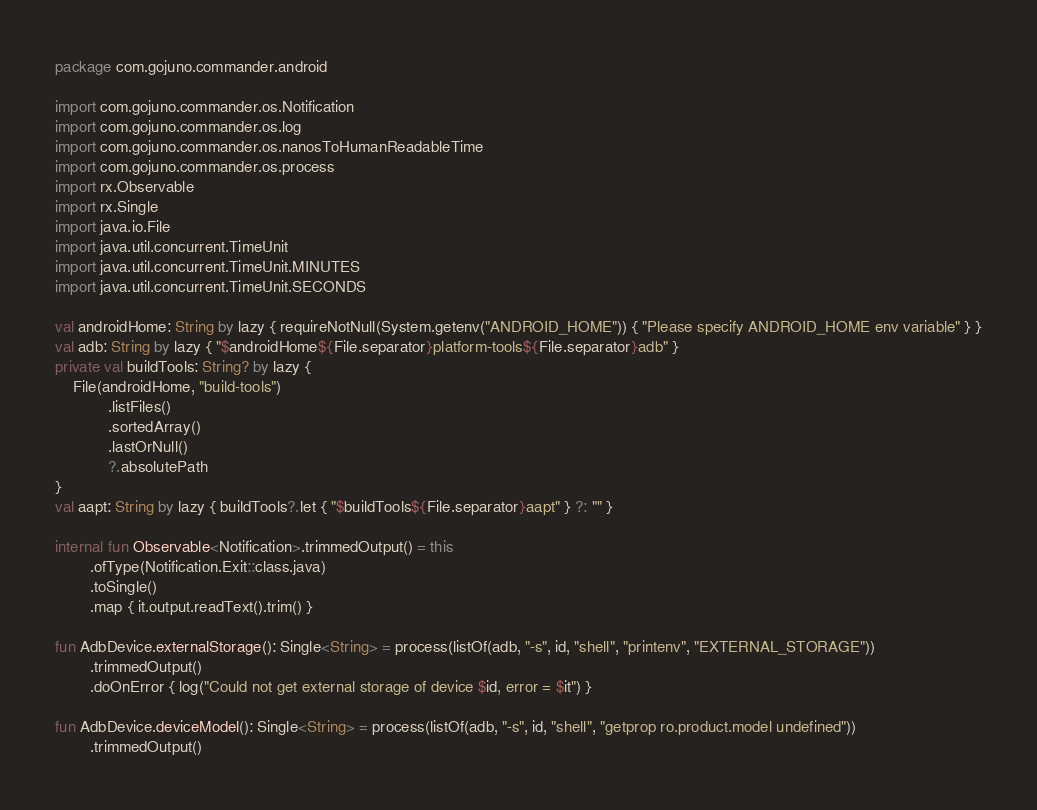Convert code to text. <code><loc_0><loc_0><loc_500><loc_500><_Kotlin_>package com.gojuno.commander.android

import com.gojuno.commander.os.Notification
import com.gojuno.commander.os.log
import com.gojuno.commander.os.nanosToHumanReadableTime
import com.gojuno.commander.os.process
import rx.Observable
import rx.Single
import java.io.File
import java.util.concurrent.TimeUnit
import java.util.concurrent.TimeUnit.MINUTES
import java.util.concurrent.TimeUnit.SECONDS

val androidHome: String by lazy { requireNotNull(System.getenv("ANDROID_HOME")) { "Please specify ANDROID_HOME env variable" } }
val adb: String by lazy { "$androidHome${File.separator}platform-tools${File.separator}adb" }
private val buildTools: String? by lazy {
    File(androidHome, "build-tools")
            .listFiles()
            .sortedArray()
            .lastOrNull()
            ?.absolutePath
}
val aapt: String by lazy { buildTools?.let { "$buildTools${File.separator}aapt" } ?: "" }

internal fun Observable<Notification>.trimmedOutput() = this
        .ofType(Notification.Exit::class.java)
        .toSingle()
        .map { it.output.readText().trim() }

fun AdbDevice.externalStorage(): Single<String> = process(listOf(adb, "-s", id, "shell", "printenv", "EXTERNAL_STORAGE"))
        .trimmedOutput()
        .doOnError { log("Could not get external storage of device $id, error = $it") }

fun AdbDevice.deviceModel(): Single<String> = process(listOf(adb, "-s", id, "shell", "getprop ro.product.model undefined"))
        .trimmedOutput()</code> 